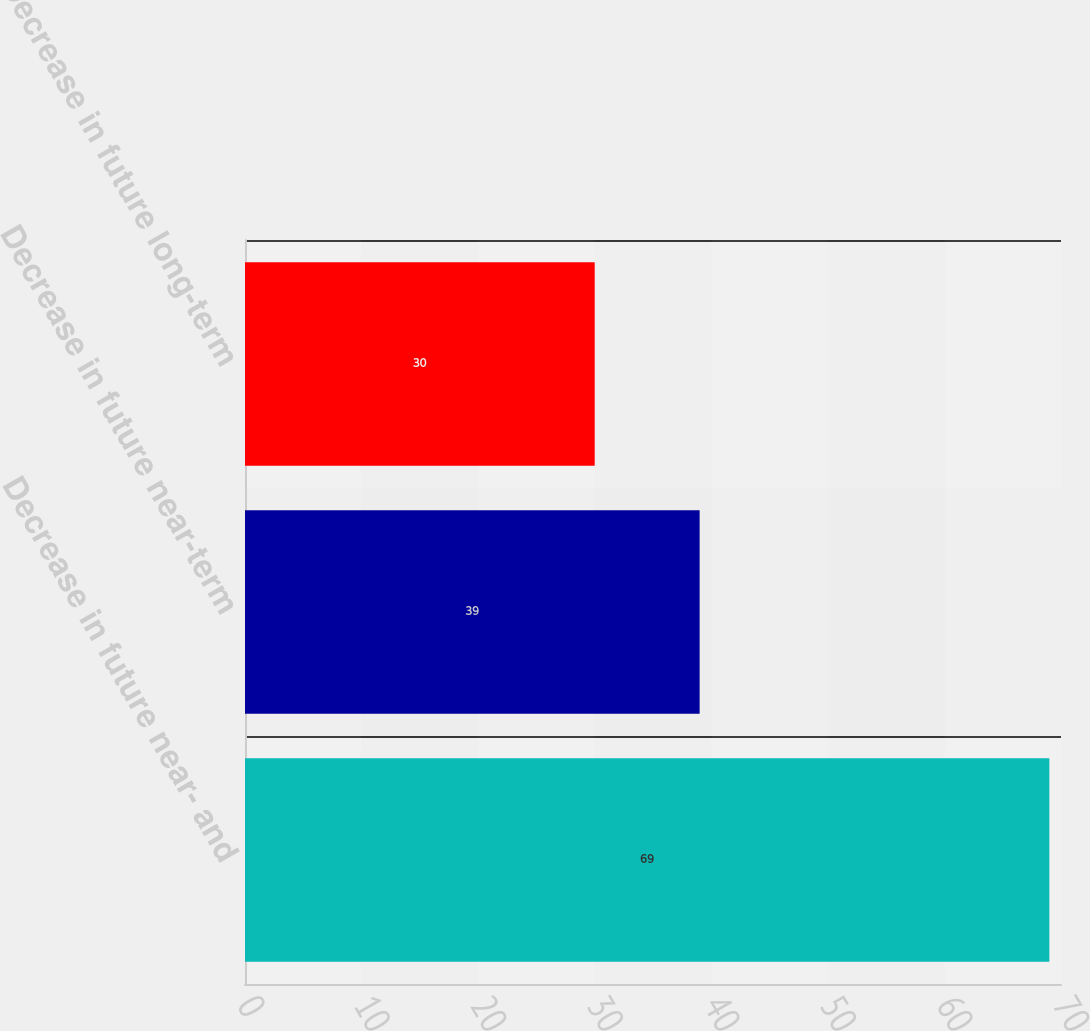Convert chart to OTSL. <chart><loc_0><loc_0><loc_500><loc_500><bar_chart><fcel>Decrease in future near- and<fcel>Decrease in future near-term<fcel>Decrease in future long-term<nl><fcel>69<fcel>39<fcel>30<nl></chart> 